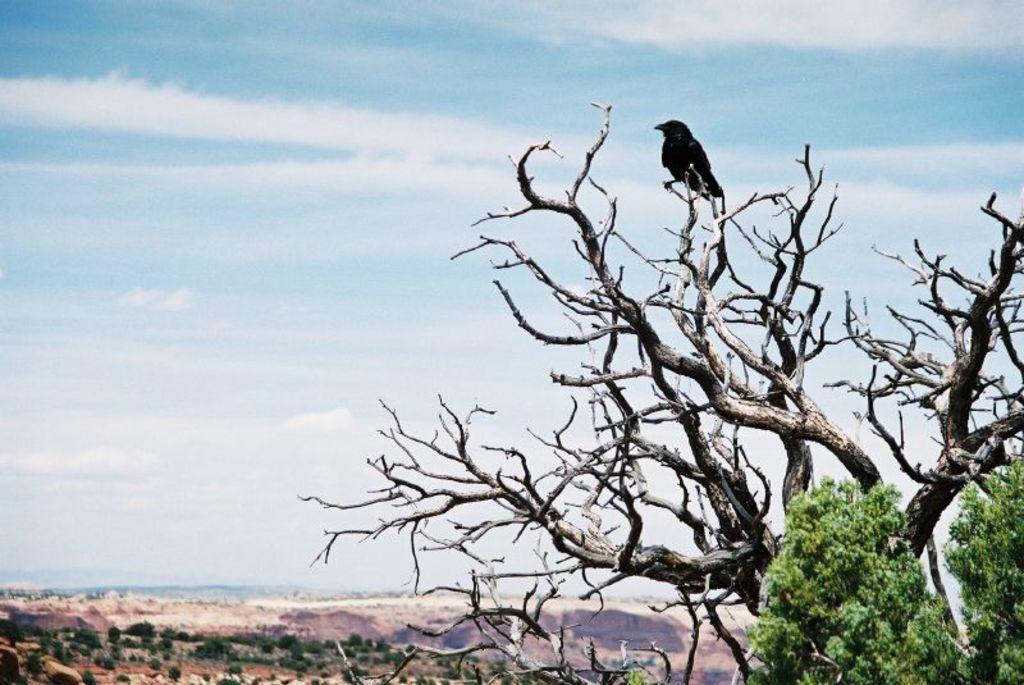Describe this image in one or two sentences. In this image we can see trees on the right side. On the tree there is a bird. In the background there is sky with clouds. 